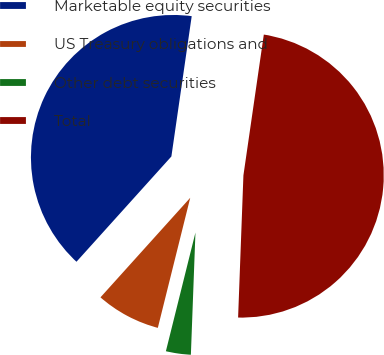<chart> <loc_0><loc_0><loc_500><loc_500><pie_chart><fcel>Marketable equity securities<fcel>US Treasury obligations and<fcel>Other debt securities<fcel>Total<nl><fcel>40.61%<fcel>7.79%<fcel>3.29%<fcel>48.3%<nl></chart> 